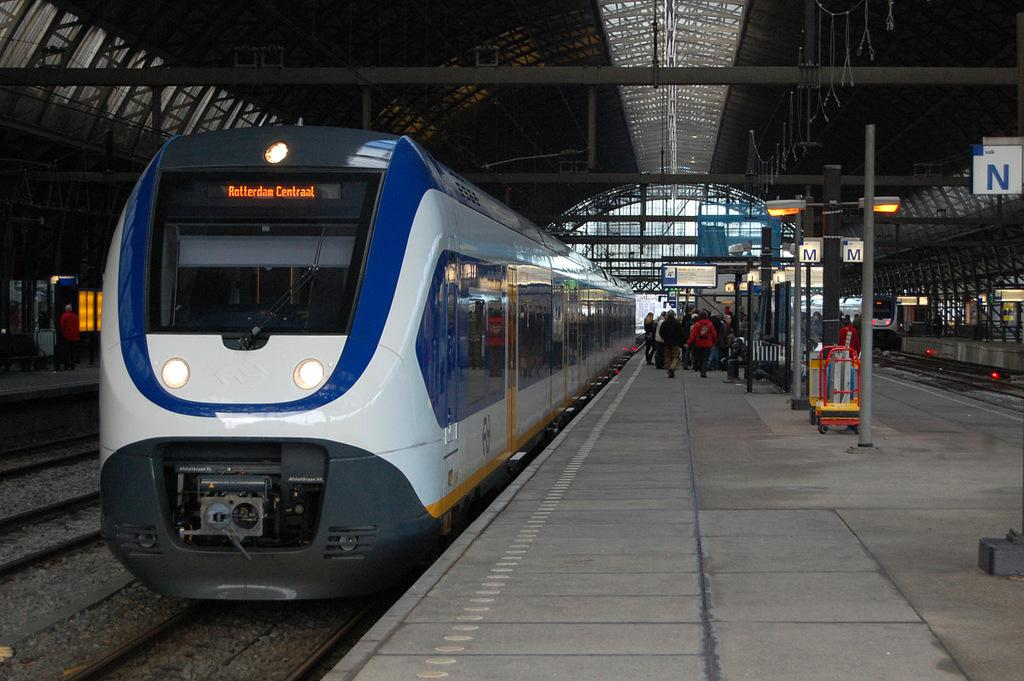What can be seen on the track in the image? There are trains on the track in the image. What is located beside the track? There is a platform beside the track. What are some people doing on the platform? Some people are walking on the platform. What type of thing is the kitty riding on the platform in the image? There is no kitty present in the image, so it cannot be riding anything on the platform. 